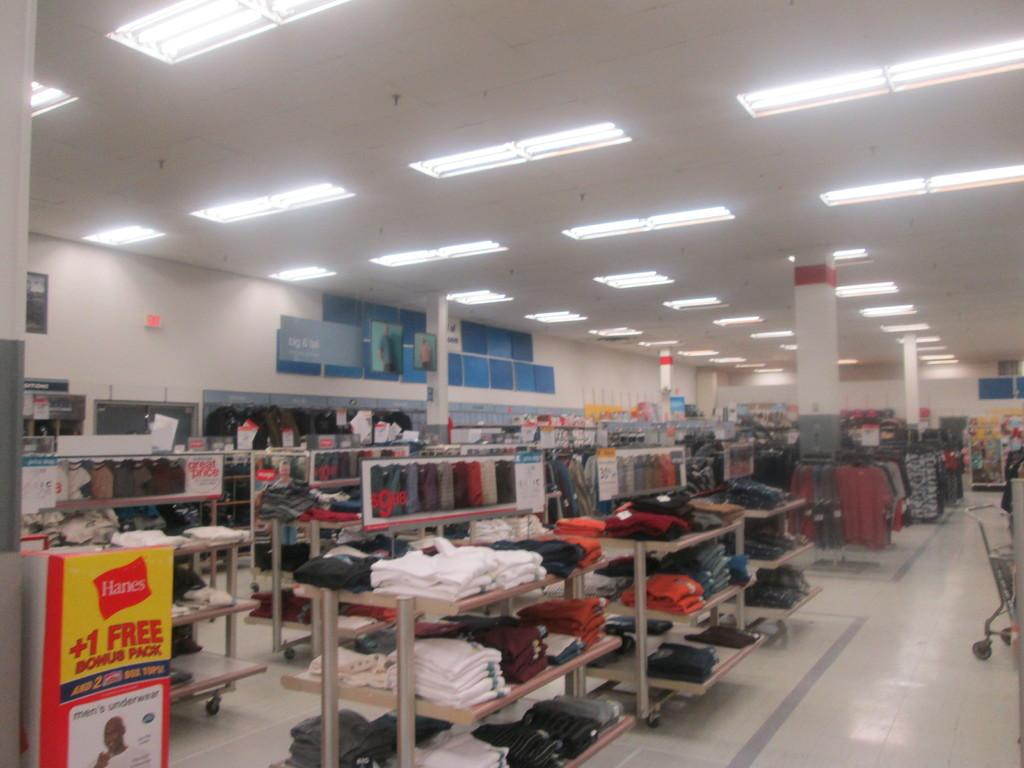<image>
Offer a succinct explanation of the picture presented. Clothing section of a store with a sign that says "+1 Free Bonus Pack". 